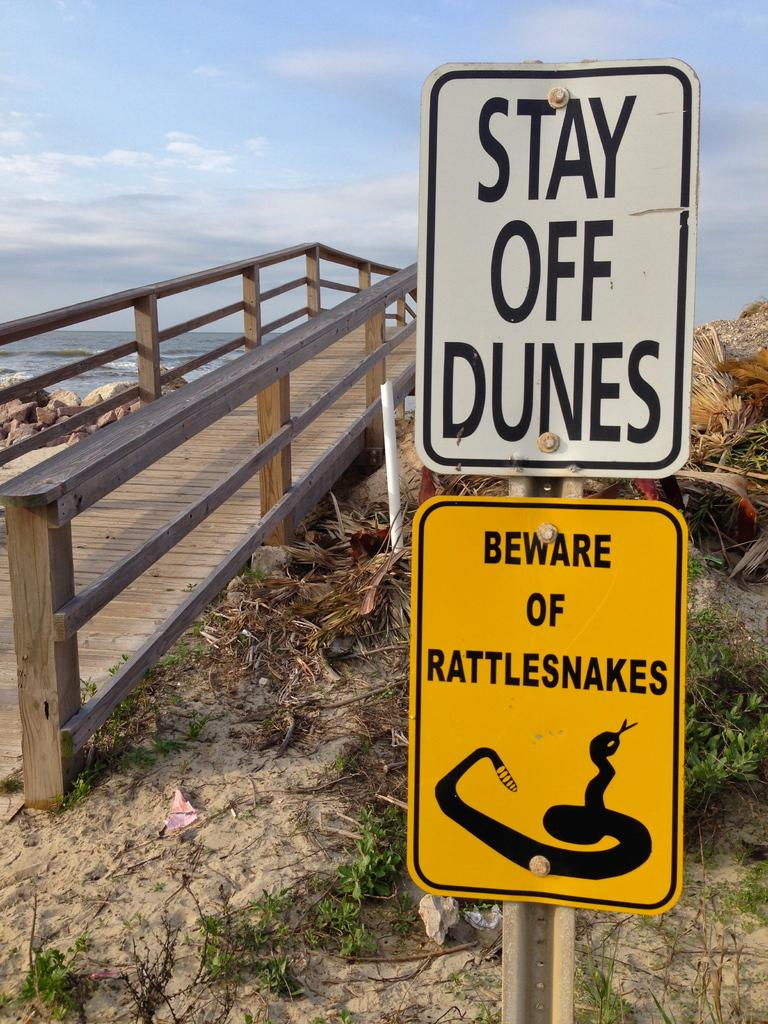<image>
Relay a brief, clear account of the picture shown. A sign at a pier by the beach that says STAY OFF DUNES and BEWARE OF RATTLESNAKES. 